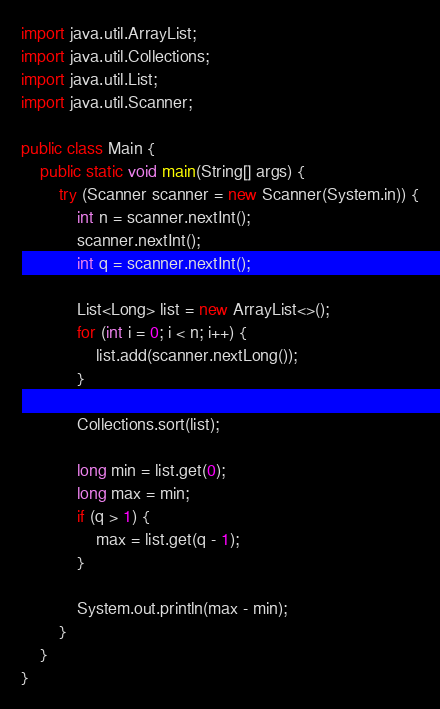Convert code to text. <code><loc_0><loc_0><loc_500><loc_500><_Java_>import java.util.ArrayList;
import java.util.Collections;
import java.util.List;
import java.util.Scanner;

public class Main {
	public static void main(String[] args) {
		try (Scanner scanner = new Scanner(System.in)) {
			int n = scanner.nextInt();
			scanner.nextInt();
			int q = scanner.nextInt();

			List<Long> list = new ArrayList<>();
			for (int i = 0; i < n; i++) {
				list.add(scanner.nextLong());
			}

			Collections.sort(list);

			long min = list.get(0);
			long max = min;
			if (q > 1) {
				max = list.get(q - 1);
			}

			System.out.println(max - min);
		}
	}
}
</code> 